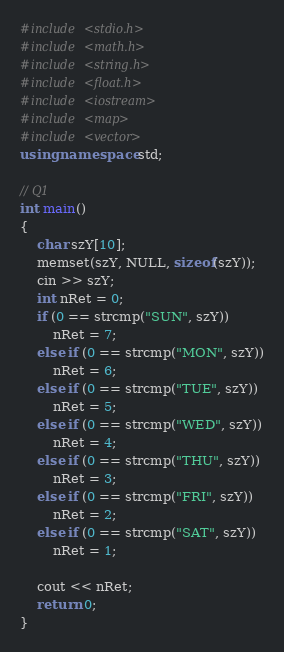Convert code to text. <code><loc_0><loc_0><loc_500><loc_500><_C++_>#include <stdio.h>
#include <math.h>
#include <string.h>
#include <float.h>
#include <iostream>
#include <map>
#include <vector>
using namespace std;

// Q1
int main()
{
	char szY[10];
	memset(szY, NULL, sizeof(szY));
	cin >> szY;
	int nRet = 0;
	if (0 == strcmp("SUN", szY))
		nRet = 7;
	else if (0 == strcmp("MON", szY))
		nRet = 6;
	else if (0 == strcmp("TUE", szY))
		nRet = 5;
	else if (0 == strcmp("WED", szY))
		nRet = 4;
	else if (0 == strcmp("THU", szY))
		nRet = 3;
	else if (0 == strcmp("FRI", szY))
		nRet = 2;
	else if (0 == strcmp("SAT", szY))
		nRet = 1;

	cout << nRet;
	return 0;
}

</code> 